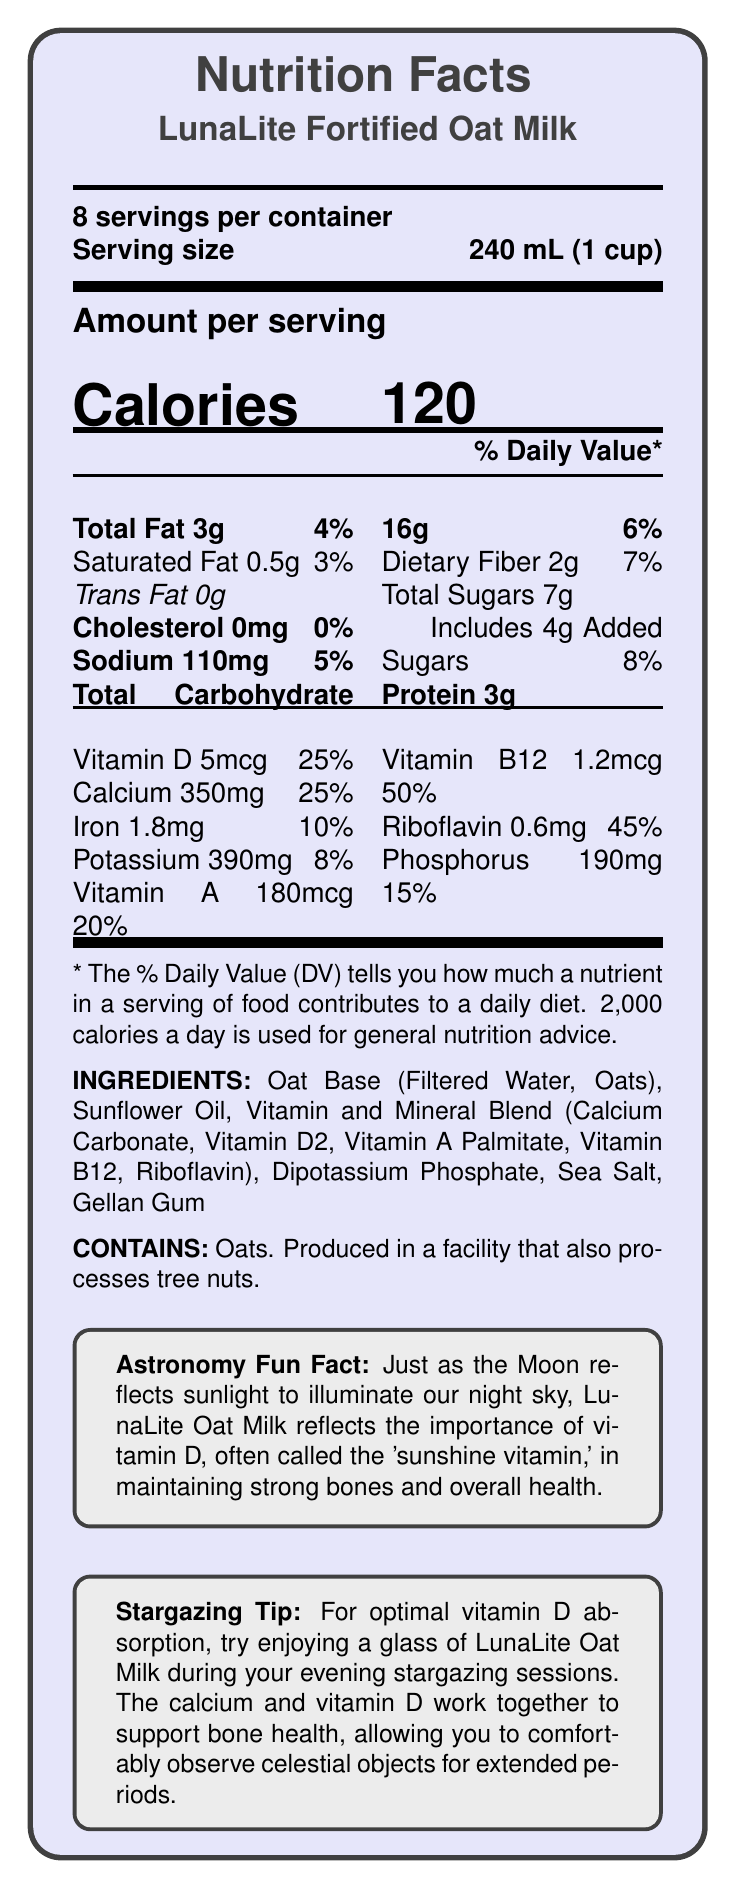what is the serving size for LunaLite Fortified Oat Milk? The serving size is explicitly mentioned as "240 mL (1 cup)" in the document.
Answer: 240 mL (1 cup) how many calories are in one serving of LunaLite Fortified Oat Milk? The document lists the calories per serving as 120.
Answer: 120 how much vitamin D is in one serving of LunaLite Fortified Oat Milk? The document lists the vitamin D content as 5mcg, which is 25% of the daily value.
Answer: 5mcg (25% Daily Value) what is the daily value percentage of calcium in a serving? The document mentions that one serving has 25% of the daily value for calcium.
Answer: 25% does LunaLite Fortified Oat Milk contain any cholesterol? The document explicitly states that LunaLite Fortified Oat Milk contains 0mg of cholesterol.
Answer: No how many servings are in the entire container? According to the document, the container has 8 servings.
Answer: 8 what is the main source of vitamin D in LunaLite Fortified Oat Milk? A. Sunflower Oil B. Calcium Carbonate C. Vitamin D2 D. Milk The ingredients list includes "Vitamin and Mineral Blend (Calcium Carbonate, Vitamin D2, Vitamin A Palmitate, Vitamin B12, Riboflavin)," indicating that Vitamin D2 is the source of vitamin D.
Answer: C. Vitamin D2 how much protein is in a serving of LunaLite Fortified Oat Milk? A. 2g B. 3g C. 5g D. 6g The document states that one serving contains 3g of protein.
Answer: B. 3g is the product vegan-friendly? The claim statements clearly mention that the product is lactose-free and vegan-friendly.
Answer: Yes what are the health claims made about LunaLite Fortified Oat Milk? The document lists these claims in the claim statements section.
Answer: Excellent source of calcium and vitamin D for bone health, Fortified with essential nutrients for older adults, Lactose-free and vegan-friendly, No artificial flavors or preservatives can the exact facilities where LunaLite Fortified Oat Milk is produced be determined from the document? The document only mentions that it is produced in a facility that also processes tree nuts, without specifying the exact facilities.
Answer: Not enough information what additional fun information does the document provide for astronomy enthusiasts? The document includes an Astronomy Fun Fact and a Stargazing Tip that relate vitamin D and calcium's benefits to bone health, along with the fun comparison to the moon reflecting sunlight.
Answer: Astronomy Fun Fact: Reflects the importance of vitamin D, often called the 'sunshine vitamin,' in maintaining strong bones and overall health. Stargazing Tip: Try enjoying a glass of LunaLite Oat Milk during evening stargazing sessions to support bone health for extended observation periods. what can you infer about LunaLite Fortified Oat Milk based on its nutrient content? The nutrient content shows high percentages of daily values for vitamin D, calcium, vitamin A, vitamin B12, and riboflavin, aimed at maintaining strong bones and general health, particularly important for older adults.
Answer: It is a nutritious option for older adults, especially beneficial for bone health, providing essential vitamins and minerals including high levels of vitamin D, calcium, vitamin A, vitamin B12, and riboflavin. 